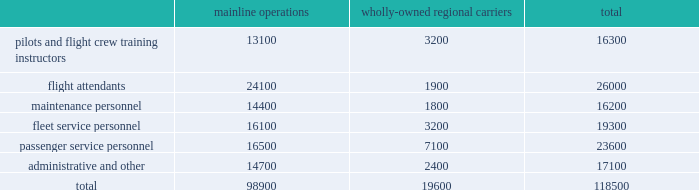Table of contents other areas in which we do business .
Depending on the scope of such regulation , certain of our facilities and operations , or the operations of our suppliers , may be subject to additional operating and other permit requirements , potentially resulting in increased operating costs .
Future regulatory developments future regulatory developments and actions could affect operations and increase operating costs for the airline industry , including our airline subsidiaries .
See part i , item 1a .
Risk factors 2013 201cif we are unable to obtain and maintain adequate facilities and infrastructure throughout our system and , at some airports , adequate slots , we may be unable to operate our existing flight schedule and to expand or change our route network in the future , which may have a material adverse impact on our operations , 201d 201cour business is subject to extensive government regulation , which may result in increases in our costs , disruptions to our operations , limits on our operating flexibility , reductions in the demand for air travel , and competitive disadvantages 201d and 201cwe are subject to many forms of environmental regulation and may incur substantial costs as a result 201d for additional information .
Employees and labor relations the airline business is labor intensive .
In 2015 , salaries , wages and benefits were our largest expenses and represented approximately 31% ( 31 % ) of our operating expenses .
The table below presents our approximate number of active full-time equivalent employees as of december 31 , 2015 .
Mainline operations wholly-owned regional carriers total .

What percentage of total active full-time equivalent employees consisted of flight attendants? 
Computations: (26000 / 118500)
Answer: 0.21941. 